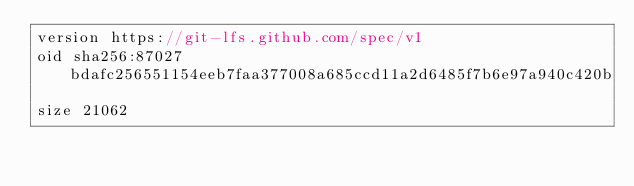Convert code to text. <code><loc_0><loc_0><loc_500><loc_500><_ObjectiveC_>version https://git-lfs.github.com/spec/v1
oid sha256:87027bdafc256551154eeb7faa377008a685ccd11a2d6485f7b6e97a940c420b
size 21062
</code> 